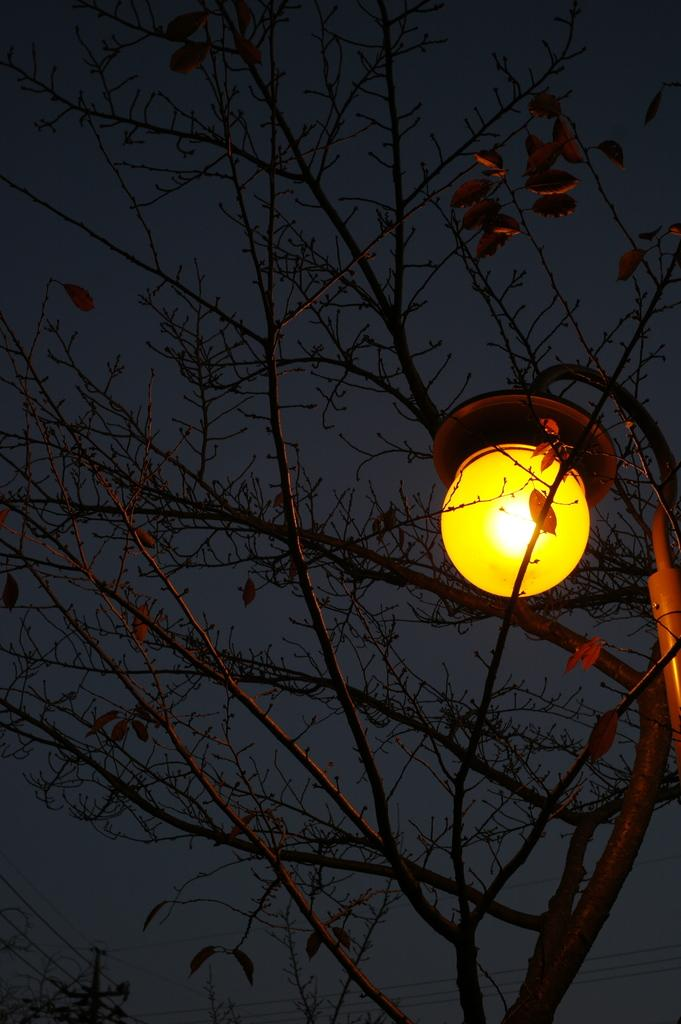What type of natural element is present in the image? There is a tree in the image. What is located near the tree? There is a light near the tree. What can be seen in the bottom left corner of the image? There is a pole in the bottom left corner of the image. What else is visible in the image besides the tree, light, and pole? There are wires visible in the image. What type of rock is being used as a mode of transport in the image? There is no rock or mode of transport present in the image. 